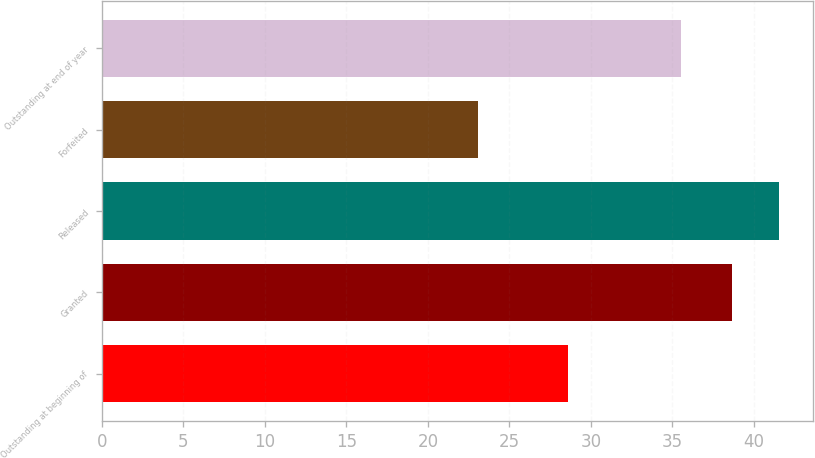Convert chart. <chart><loc_0><loc_0><loc_500><loc_500><bar_chart><fcel>Outstanding at beginning of<fcel>Granted<fcel>Released<fcel>Forfeited<fcel>Outstanding at end of year<nl><fcel>28.58<fcel>38.68<fcel>41.57<fcel>23.06<fcel>35.55<nl></chart> 